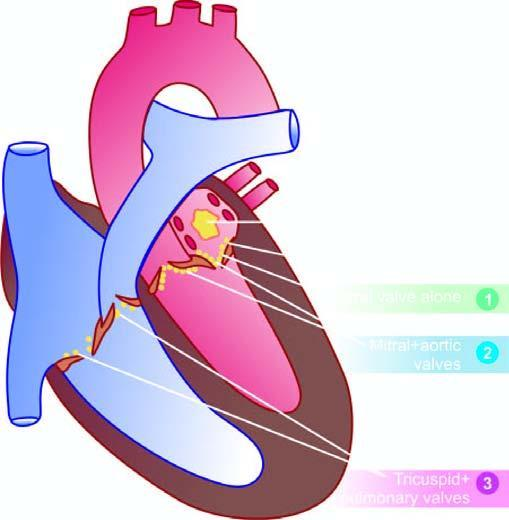what are serial numbers 1, 2 and 3 are denoted for?
Answer the question using a single word or phrase. The frequency of valvular involvement 